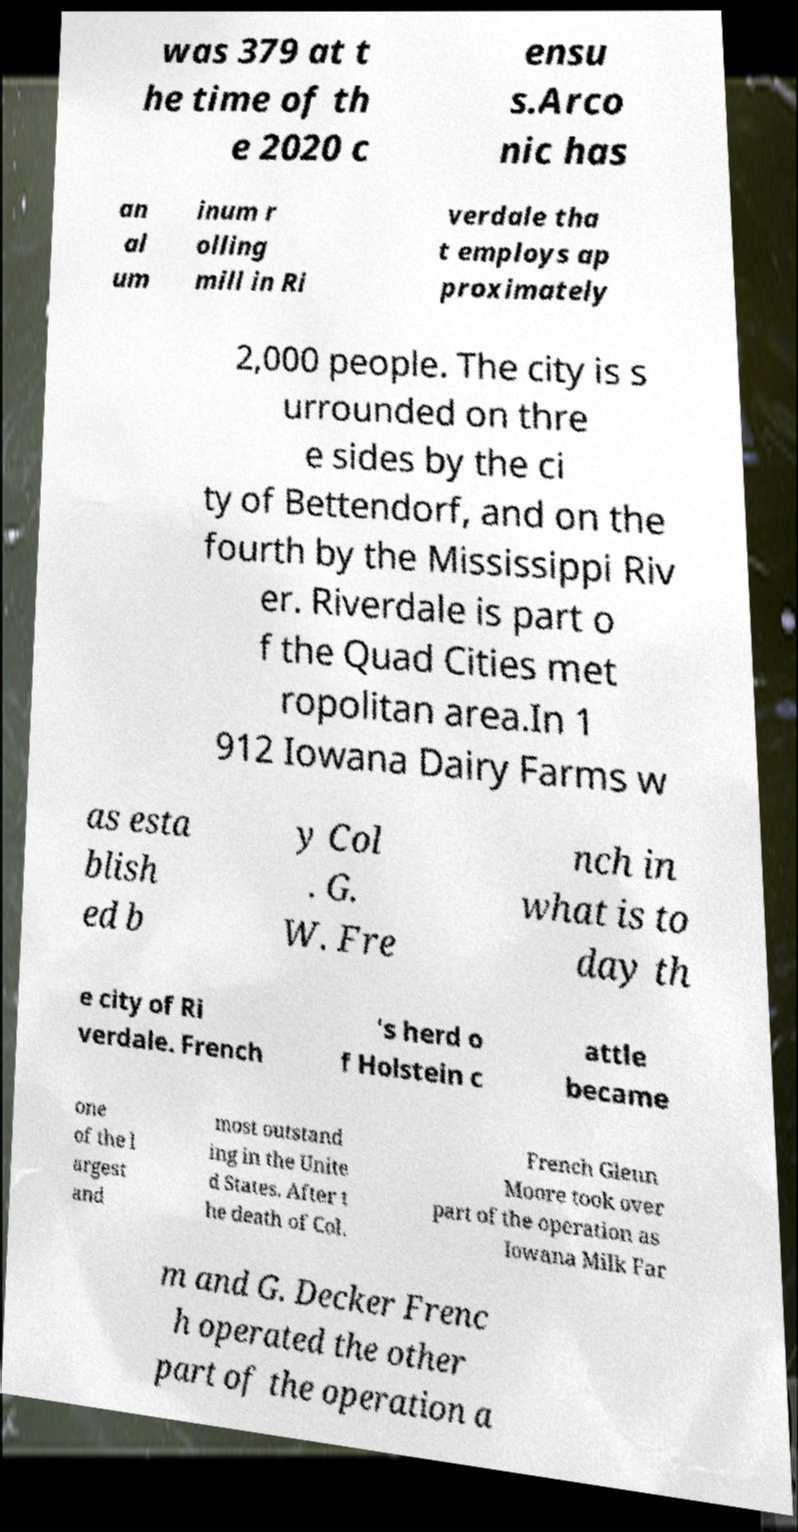Please read and relay the text visible in this image. What does it say? was 379 at t he time of th e 2020 c ensu s.Arco nic has an al um inum r olling mill in Ri verdale tha t employs ap proximately 2,000 people. The city is s urrounded on thre e sides by the ci ty of Bettendorf, and on the fourth by the Mississippi Riv er. Riverdale is part o f the Quad Cities met ropolitan area.In 1 912 Iowana Dairy Farms w as esta blish ed b y Col . G. W. Fre nch in what is to day th e city of Ri verdale. French 's herd o f Holstein c attle became one of the l argest and most outstand ing in the Unite d States. After t he death of Col. French Glenn Moore took over part of the operation as Iowana Milk Far m and G. Decker Frenc h operated the other part of the operation a 